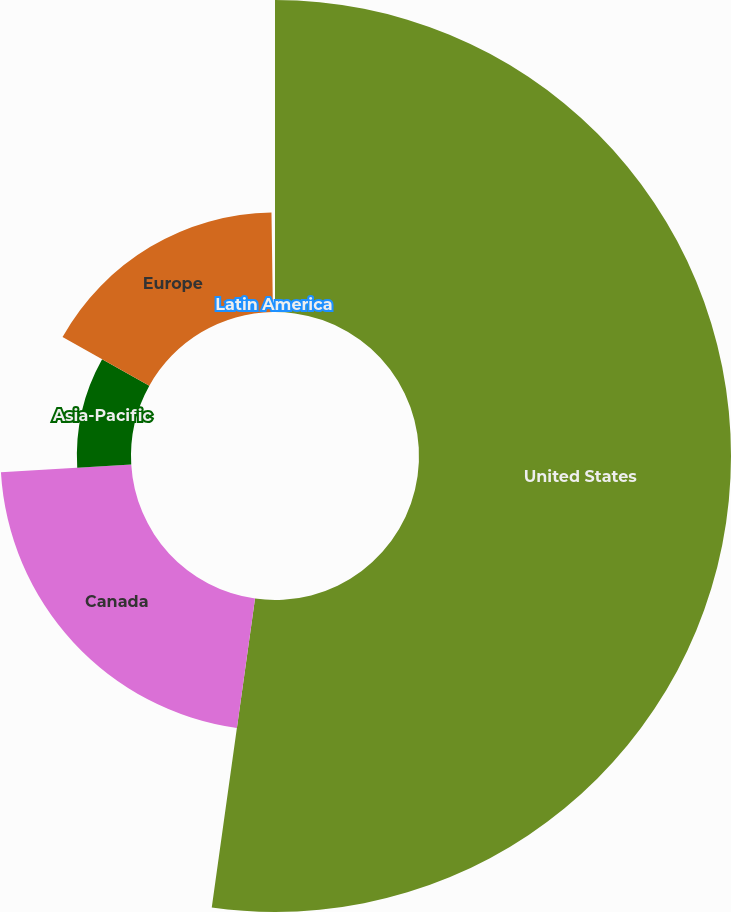<chart> <loc_0><loc_0><loc_500><loc_500><pie_chart><fcel>United States<fcel>Canada<fcel>Asia-Pacific<fcel>Europe<fcel>Latin America<nl><fcel>52.22%<fcel>21.85%<fcel>9.06%<fcel>16.65%<fcel>0.23%<nl></chart> 